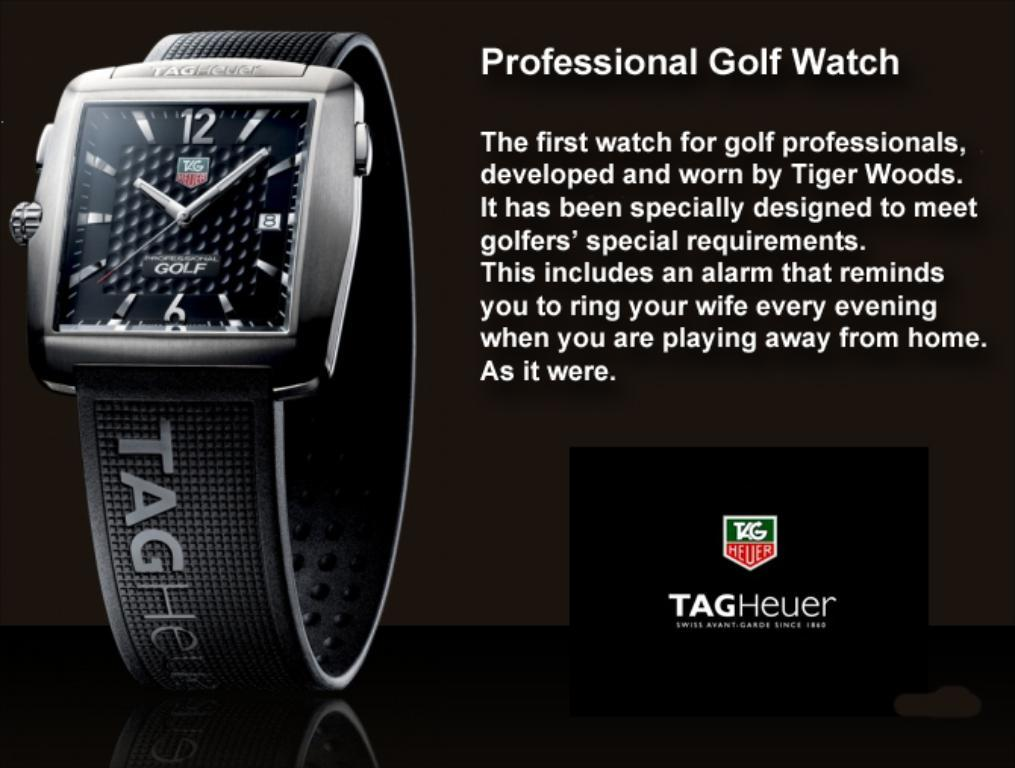<image>
Share a concise interpretation of the image provided. Profressional Golf Watch by Tag Heuer, shows the time 10:08. 